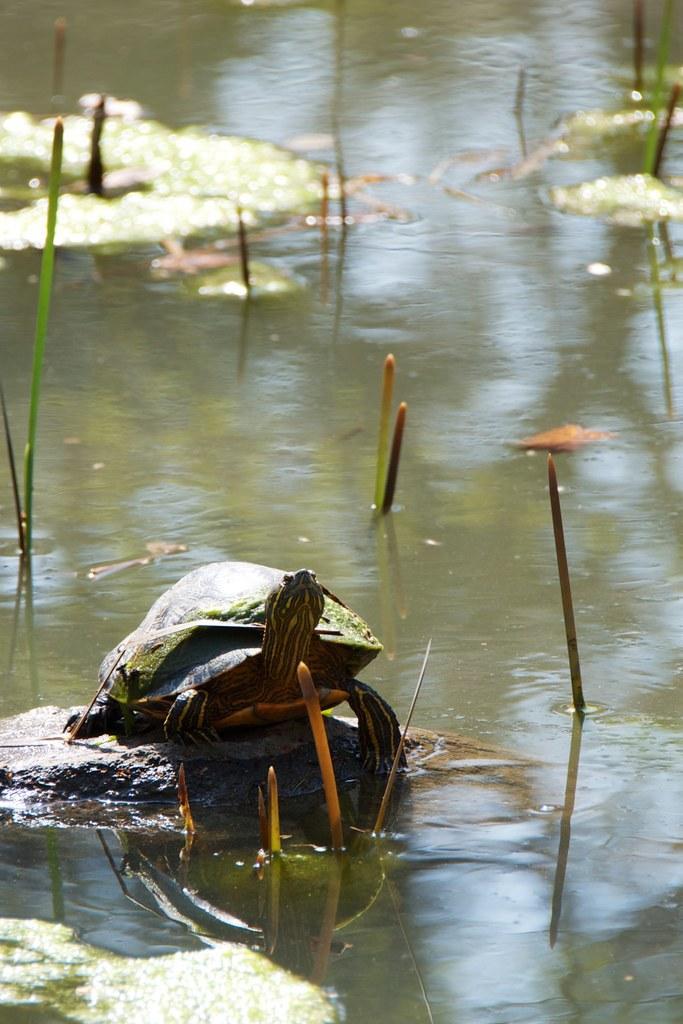In one or two sentences, can you explain what this image depicts? In this image we can see a tortoise on the rock. We can also see some plants in a water body. 